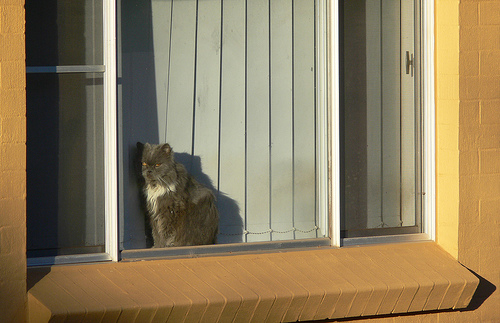<image>
Can you confirm if the cat is on the window sill? No. The cat is not positioned on the window sill. They may be near each other, but the cat is not supported by or resting on top of the window sill. 